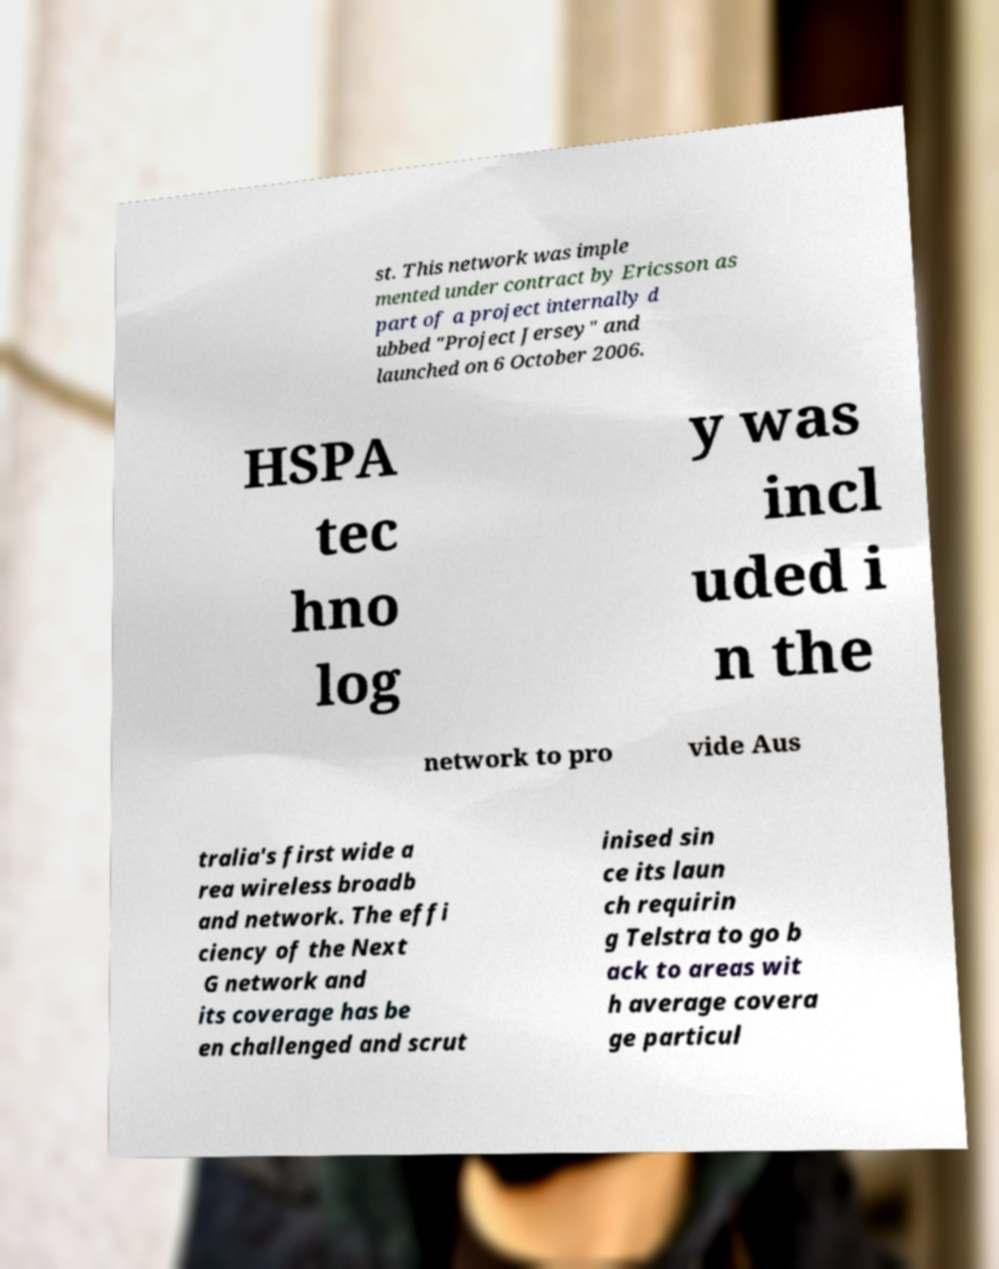Can you read and provide the text displayed in the image?This photo seems to have some interesting text. Can you extract and type it out for me? st. This network was imple mented under contract by Ericsson as part of a project internally d ubbed "Project Jersey" and launched on 6 October 2006. HSPA tec hno log y was incl uded i n the network to pro vide Aus tralia's first wide a rea wireless broadb and network. The effi ciency of the Next G network and its coverage has be en challenged and scrut inised sin ce its laun ch requirin g Telstra to go b ack to areas wit h average covera ge particul 